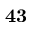<formula> <loc_0><loc_0><loc_500><loc_500>4 3</formula> 